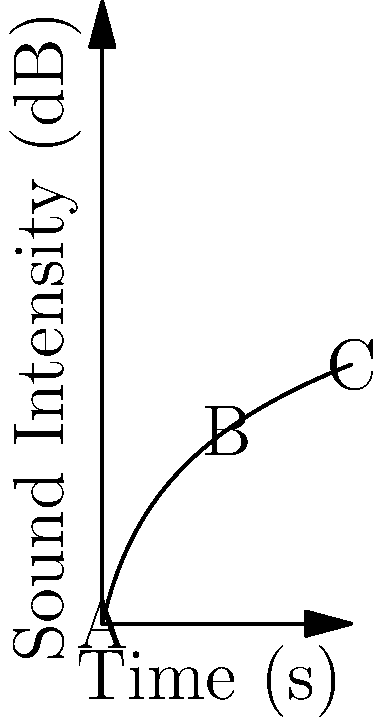The graph shows the sound intensity of a musical performance over time, measured in decibels (dB) on a logarithmic scale. If the intensity at point A is $I_A$ and at point C is $I_C$, what is the average rate of change of intensity between these two points in dB/s? To solve this problem, we'll follow these steps:

1) First, we need to identify the coordinates of points A and C:
   Point A: $(0, 0)$
   Point C: $(10, 10\log_{10}(11))$

2) The average rate of change is given by the formula:
   $\text{Average rate of change} = \frac{\text{Change in y}}{\text{Change in x}}$

3) In this case:
   $\text{Change in y} = 10\log_{10}(11) - 0 = 10\log_{10}(11)$
   $\text{Change in x} = 10 - 0 = 10$

4) Substituting into the formula:
   $\text{Average rate of change} = \frac{10\log_{10}(11)}{10} = \log_{10}(11)$

5) Using a calculator or logarithm table, we can find that:
   $\log_{10}(11) \approx 1.0414$

Therefore, the average rate of change of intensity between points A and C is approximately 1.0414 dB/s.
Answer: $\log_{10}(11)$ dB/s 